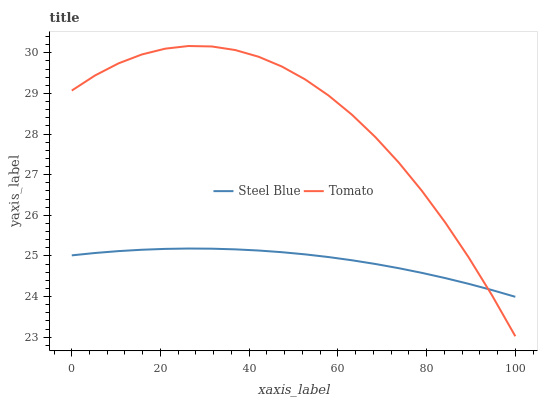Does Steel Blue have the minimum area under the curve?
Answer yes or no. Yes. Does Tomato have the maximum area under the curve?
Answer yes or no. Yes. Does Steel Blue have the maximum area under the curve?
Answer yes or no. No. Is Steel Blue the smoothest?
Answer yes or no. Yes. Is Tomato the roughest?
Answer yes or no. Yes. Is Steel Blue the roughest?
Answer yes or no. No. Does Tomato have the lowest value?
Answer yes or no. Yes. Does Steel Blue have the lowest value?
Answer yes or no. No. Does Tomato have the highest value?
Answer yes or no. Yes. Does Steel Blue have the highest value?
Answer yes or no. No. Does Tomato intersect Steel Blue?
Answer yes or no. Yes. Is Tomato less than Steel Blue?
Answer yes or no. No. Is Tomato greater than Steel Blue?
Answer yes or no. No. 